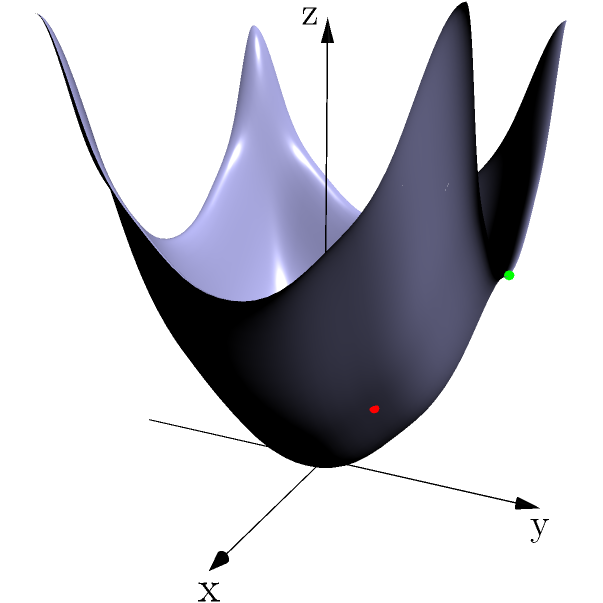In the context of machine learning for predicting job placement success, consider the 3D coordinate system shown above. It represents three key factors: x-axis for technical skills, y-axis for soft skills, and z-axis for internship experience. Three data points are plotted: A(1,1,2) in red, B(-1,-1,2) in blue, and C(0,2,4) in green. Which point represents a student with the highest likelihood of successful job placement, and why? To determine which student has the highest likelihood of successful job placement, we need to analyze the three data points in the context of the given dimensions:

1. Point A (1,1,2) in red:
   - Technical skills: 1 (slightly above average)
   - Soft skills: 1 (slightly above average)
   - Internship experience: 2 (moderate)

2. Point B (-1,-1,2) in blue:
   - Technical skills: -1 (below average)
   - Soft skills: -1 (below average)
   - Internship experience: 2 (moderate)

3. Point C (0,2,4) in green:
   - Technical skills: 0 (average)
   - Soft skills: 2 (well above average)
   - Internship experience: 4 (high)

Analyzing these points:
1. Point A shows balanced but only slightly above-average skills with moderate internship experience.
2. Point B has below-average skills in both technical and soft skills areas, despite moderate internship experience.
3. Point C demonstrates average technical skills, but excels in soft skills and has the highest internship experience.

In the context of job placement success, Point C (0,2,4) represents the student with the highest likelihood of successful job placement. This is because:

1. Soft skills (y-axis) are crucial for job interviews and workplace success, and this student excels in this area.
2. Internship experience (z-axis) is often a key differentiator for employers, and this student has the highest level among the three.
3. While technical skills (x-axis) are average, the combination of strong soft skills and substantial internship experience often outweighs slightly higher technical skills in many job placement scenarios.

Therefore, the student represented by Point C (0,2,4) is likely to have the best job placement prospects among the three data points.
Answer: Point C (0,2,4) 